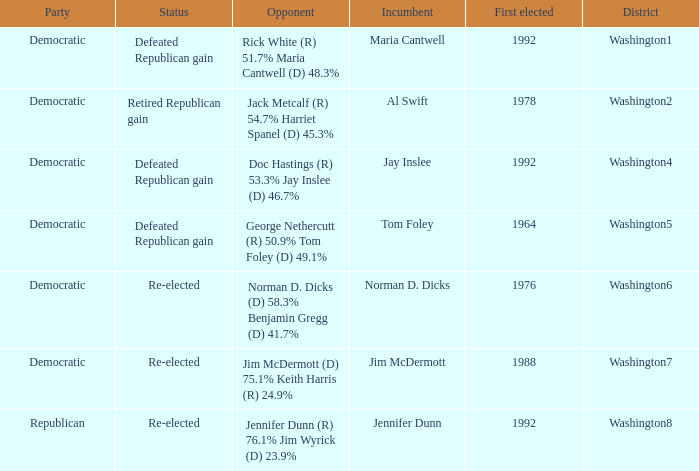What was the result of the election of doc hastings (r) 53.3% jay inslee (d) 46.7% Defeated Republican gain. 